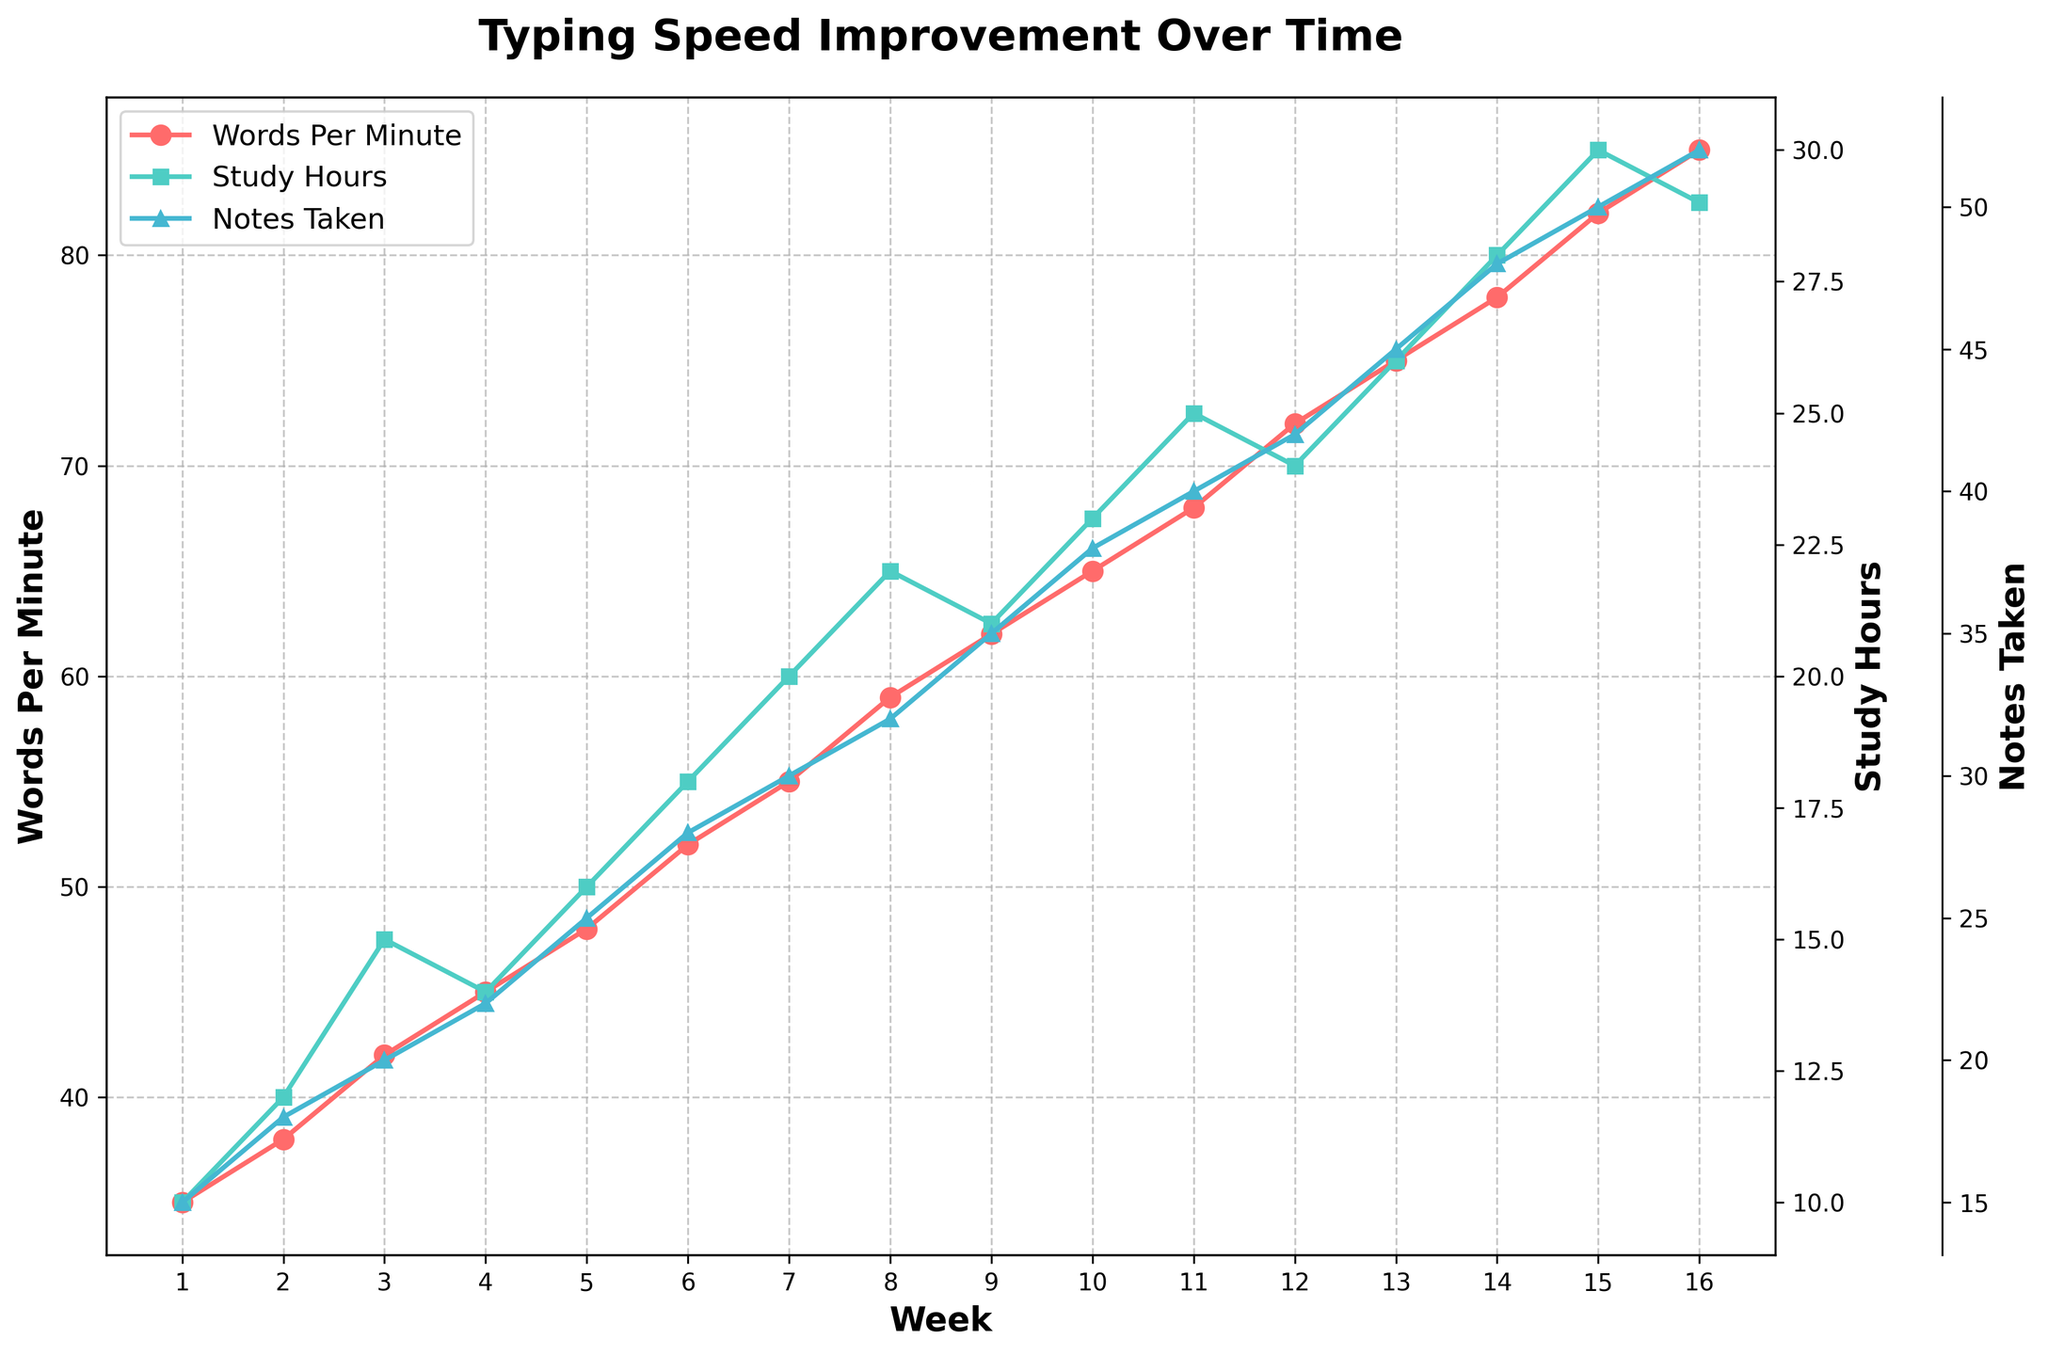What is the overall trend in typing speed from week 1 to week 16? By looking at the red line, which represents Words Per Minute (WPM), we observe a steady increase from 35 WPM in week 1 to 85 WPM in week 16. This indicates a consistent improvement in typing speed over time.
Answer: Steady increase In which week does the largest jump in Words Per Minute occur? To find the largest jump, we need to look at the differences between consecutive weeks. The largest jump is between week 3 (42 WPM) and week 4 (45 WPM), where there is a 3 WPM increase.
Answer: Week 4 Compare the trends of Study Hours and Notes Taken from week 1 to week 16. The green and blue lines represent Study Hours and Notes Taken, respectively. Both lines show a general upward trend. Initially, Study Hours and Notes Taken grow steadily, but Notes Taken has a slightly sharper increase towards the end.
Answer: Both upward, Notes Taken sharper How many study hours were required to reach 72 Words Per Minute? By referring to the chart, we see that at week 12, the Words Per Minute reaches 72. At this point, the green line indicates that Study Hours is 24.
Answer: 24 hours Is the relationship between Study Hours and Words Per Minute linear throughout the observed periods? Examining the figure, both lines consistently increase but not always at the same rate. Initially, small increases in Study Hours yield significant WPM improvements, but later, it takes more Study Hours to achieve smaller increments in WPM, indicating a nonlinear relationship.
Answer: Nonlinear What is the difference in Notes Taken between week 5 and week 10? At week 5, Notes Taken is 25, and at week 10, it is 38. Subtracting these gives 38 - 25 = 13 notes.
Answer: 13 notes When do Study Hours peak, and what is the corresponding Words Per Minute? Study Hours peak at week 15 with 30 hours. At this point, the Words Per Minute is 82.
Answer: Week 15, 82 WPM Which week has the highest ratio of WPM to Notes Taken? To find this ratio, divide WPM by Notes Taken for each week. The calculations show the highest ratio is at week 1 with 35 WPM / 15 Notes = 2.33.
Answer: Week 1 From weeks 1 to 16, how much more did Notes Taken increase compared to Words Per Minute? Notes Taken increased from 15 to 52, a difference of 52 - 15 = 37. Words Per Minute increased from 35 to 85, a difference of 85 - 35 = 50. Hence, Words Per Minute increased by 50 - 37 = 13 more units.
Answer: 13 units What would be a likely prediction for Study Hours in week 17 considering the trends? Observing the trend where Study Hours roughly increase by 1-2 hours each week towards the end, we can predict an increase of approximately 1-2 hours from week 16. Therefore, in week 17, Study Hours would likely be around 31 hours.
Answer: Around 31 hours 